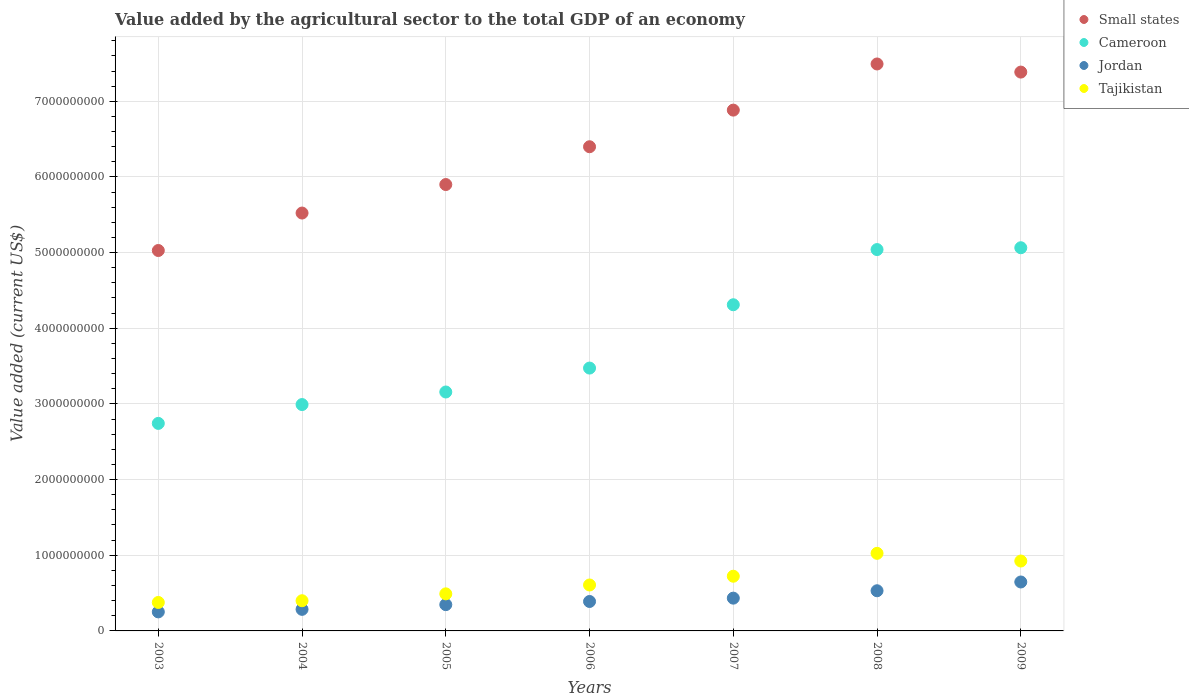Is the number of dotlines equal to the number of legend labels?
Provide a succinct answer. Yes. What is the value added by the agricultural sector to the total GDP in Small states in 2008?
Provide a short and direct response. 7.49e+09. Across all years, what is the maximum value added by the agricultural sector to the total GDP in Cameroon?
Make the answer very short. 5.06e+09. Across all years, what is the minimum value added by the agricultural sector to the total GDP in Tajikistan?
Your response must be concise. 3.76e+08. In which year was the value added by the agricultural sector to the total GDP in Jordan maximum?
Provide a short and direct response. 2009. What is the total value added by the agricultural sector to the total GDP in Jordan in the graph?
Your answer should be compact. 2.88e+09. What is the difference between the value added by the agricultural sector to the total GDP in Small states in 2007 and that in 2008?
Your answer should be compact. -6.10e+08. What is the difference between the value added by the agricultural sector to the total GDP in Tajikistan in 2003 and the value added by the agricultural sector to the total GDP in Small states in 2008?
Provide a succinct answer. -7.12e+09. What is the average value added by the agricultural sector to the total GDP in Tajikistan per year?
Offer a very short reply. 6.49e+08. In the year 2008, what is the difference between the value added by the agricultural sector to the total GDP in Jordan and value added by the agricultural sector to the total GDP in Tajikistan?
Provide a short and direct response. -4.95e+08. What is the ratio of the value added by the agricultural sector to the total GDP in Jordan in 2008 to that in 2009?
Provide a short and direct response. 0.82. What is the difference between the highest and the second highest value added by the agricultural sector to the total GDP in Tajikistan?
Your answer should be very brief. 1.02e+08. What is the difference between the highest and the lowest value added by the agricultural sector to the total GDP in Cameroon?
Give a very brief answer. 2.32e+09. In how many years, is the value added by the agricultural sector to the total GDP in Cameroon greater than the average value added by the agricultural sector to the total GDP in Cameroon taken over all years?
Ensure brevity in your answer.  3. Is the value added by the agricultural sector to the total GDP in Tajikistan strictly greater than the value added by the agricultural sector to the total GDP in Cameroon over the years?
Make the answer very short. No. Is the value added by the agricultural sector to the total GDP in Small states strictly less than the value added by the agricultural sector to the total GDP in Cameroon over the years?
Offer a very short reply. No. How many dotlines are there?
Your response must be concise. 4. What is the difference between two consecutive major ticks on the Y-axis?
Provide a short and direct response. 1.00e+09. Does the graph contain any zero values?
Provide a succinct answer. No. Where does the legend appear in the graph?
Make the answer very short. Top right. What is the title of the graph?
Make the answer very short. Value added by the agricultural sector to the total GDP of an economy. Does "Portugal" appear as one of the legend labels in the graph?
Keep it short and to the point. No. What is the label or title of the X-axis?
Your answer should be very brief. Years. What is the label or title of the Y-axis?
Offer a very short reply. Value added (current US$). What is the Value added (current US$) of Small states in 2003?
Offer a terse response. 5.03e+09. What is the Value added (current US$) in Cameroon in 2003?
Your answer should be very brief. 2.74e+09. What is the Value added (current US$) of Jordan in 2003?
Provide a succinct answer. 2.52e+08. What is the Value added (current US$) in Tajikistan in 2003?
Make the answer very short. 3.76e+08. What is the Value added (current US$) of Small states in 2004?
Ensure brevity in your answer.  5.52e+09. What is the Value added (current US$) of Cameroon in 2004?
Ensure brevity in your answer.  2.99e+09. What is the Value added (current US$) of Jordan in 2004?
Provide a succinct answer. 2.85e+08. What is the Value added (current US$) in Tajikistan in 2004?
Offer a terse response. 3.99e+08. What is the Value added (current US$) of Small states in 2005?
Provide a succinct answer. 5.90e+09. What is the Value added (current US$) of Cameroon in 2005?
Give a very brief answer. 3.16e+09. What is the Value added (current US$) in Jordan in 2005?
Offer a very short reply. 3.47e+08. What is the Value added (current US$) of Tajikistan in 2005?
Keep it short and to the point. 4.90e+08. What is the Value added (current US$) of Small states in 2006?
Your answer should be compact. 6.40e+09. What is the Value added (current US$) in Cameroon in 2006?
Your answer should be very brief. 3.47e+09. What is the Value added (current US$) in Jordan in 2006?
Offer a very short reply. 3.89e+08. What is the Value added (current US$) in Tajikistan in 2006?
Provide a succinct answer. 6.07e+08. What is the Value added (current US$) of Small states in 2007?
Your answer should be very brief. 6.88e+09. What is the Value added (current US$) in Cameroon in 2007?
Ensure brevity in your answer.  4.31e+09. What is the Value added (current US$) of Jordan in 2007?
Your answer should be compact. 4.33e+08. What is the Value added (current US$) in Tajikistan in 2007?
Offer a very short reply. 7.23e+08. What is the Value added (current US$) of Small states in 2008?
Offer a very short reply. 7.49e+09. What is the Value added (current US$) in Cameroon in 2008?
Keep it short and to the point. 5.04e+09. What is the Value added (current US$) of Jordan in 2008?
Offer a terse response. 5.31e+08. What is the Value added (current US$) of Tajikistan in 2008?
Give a very brief answer. 1.03e+09. What is the Value added (current US$) in Small states in 2009?
Provide a short and direct response. 7.39e+09. What is the Value added (current US$) of Cameroon in 2009?
Offer a terse response. 5.06e+09. What is the Value added (current US$) of Jordan in 2009?
Ensure brevity in your answer.  6.47e+08. What is the Value added (current US$) in Tajikistan in 2009?
Provide a short and direct response. 9.24e+08. Across all years, what is the maximum Value added (current US$) in Small states?
Offer a very short reply. 7.49e+09. Across all years, what is the maximum Value added (current US$) of Cameroon?
Provide a short and direct response. 5.06e+09. Across all years, what is the maximum Value added (current US$) in Jordan?
Make the answer very short. 6.47e+08. Across all years, what is the maximum Value added (current US$) in Tajikistan?
Provide a short and direct response. 1.03e+09. Across all years, what is the minimum Value added (current US$) in Small states?
Your answer should be very brief. 5.03e+09. Across all years, what is the minimum Value added (current US$) in Cameroon?
Keep it short and to the point. 2.74e+09. Across all years, what is the minimum Value added (current US$) of Jordan?
Offer a terse response. 2.52e+08. Across all years, what is the minimum Value added (current US$) of Tajikistan?
Your response must be concise. 3.76e+08. What is the total Value added (current US$) of Small states in the graph?
Offer a very short reply. 4.46e+1. What is the total Value added (current US$) in Cameroon in the graph?
Give a very brief answer. 2.68e+1. What is the total Value added (current US$) of Jordan in the graph?
Give a very brief answer. 2.88e+09. What is the total Value added (current US$) in Tajikistan in the graph?
Make the answer very short. 4.54e+09. What is the difference between the Value added (current US$) in Small states in 2003 and that in 2004?
Your answer should be very brief. -4.95e+08. What is the difference between the Value added (current US$) in Cameroon in 2003 and that in 2004?
Provide a short and direct response. -2.49e+08. What is the difference between the Value added (current US$) in Jordan in 2003 and that in 2004?
Offer a very short reply. -3.35e+07. What is the difference between the Value added (current US$) in Tajikistan in 2003 and that in 2004?
Offer a very short reply. -2.28e+07. What is the difference between the Value added (current US$) in Small states in 2003 and that in 2005?
Provide a succinct answer. -8.72e+08. What is the difference between the Value added (current US$) of Cameroon in 2003 and that in 2005?
Give a very brief answer. -4.15e+08. What is the difference between the Value added (current US$) in Jordan in 2003 and that in 2005?
Offer a terse response. -9.57e+07. What is the difference between the Value added (current US$) of Tajikistan in 2003 and that in 2005?
Your answer should be very brief. -1.14e+08. What is the difference between the Value added (current US$) in Small states in 2003 and that in 2006?
Offer a terse response. -1.37e+09. What is the difference between the Value added (current US$) in Cameroon in 2003 and that in 2006?
Give a very brief answer. -7.31e+08. What is the difference between the Value added (current US$) of Jordan in 2003 and that in 2006?
Ensure brevity in your answer.  -1.38e+08. What is the difference between the Value added (current US$) of Tajikistan in 2003 and that in 2006?
Provide a short and direct response. -2.31e+08. What is the difference between the Value added (current US$) of Small states in 2003 and that in 2007?
Ensure brevity in your answer.  -1.86e+09. What is the difference between the Value added (current US$) in Cameroon in 2003 and that in 2007?
Give a very brief answer. -1.57e+09. What is the difference between the Value added (current US$) in Jordan in 2003 and that in 2007?
Your response must be concise. -1.82e+08. What is the difference between the Value added (current US$) of Tajikistan in 2003 and that in 2007?
Offer a terse response. -3.47e+08. What is the difference between the Value added (current US$) of Small states in 2003 and that in 2008?
Your answer should be very brief. -2.47e+09. What is the difference between the Value added (current US$) in Cameroon in 2003 and that in 2008?
Your answer should be compact. -2.30e+09. What is the difference between the Value added (current US$) of Jordan in 2003 and that in 2008?
Your answer should be compact. -2.79e+08. What is the difference between the Value added (current US$) of Tajikistan in 2003 and that in 2008?
Your answer should be compact. -6.49e+08. What is the difference between the Value added (current US$) of Small states in 2003 and that in 2009?
Offer a very short reply. -2.36e+09. What is the difference between the Value added (current US$) of Cameroon in 2003 and that in 2009?
Offer a terse response. -2.32e+09. What is the difference between the Value added (current US$) in Jordan in 2003 and that in 2009?
Provide a short and direct response. -3.95e+08. What is the difference between the Value added (current US$) in Tajikistan in 2003 and that in 2009?
Provide a succinct answer. -5.48e+08. What is the difference between the Value added (current US$) of Small states in 2004 and that in 2005?
Offer a very short reply. -3.77e+08. What is the difference between the Value added (current US$) of Cameroon in 2004 and that in 2005?
Offer a very short reply. -1.66e+08. What is the difference between the Value added (current US$) in Jordan in 2004 and that in 2005?
Provide a short and direct response. -6.22e+07. What is the difference between the Value added (current US$) of Tajikistan in 2004 and that in 2005?
Your answer should be compact. -9.09e+07. What is the difference between the Value added (current US$) in Small states in 2004 and that in 2006?
Your response must be concise. -8.76e+08. What is the difference between the Value added (current US$) in Cameroon in 2004 and that in 2006?
Your answer should be compact. -4.82e+08. What is the difference between the Value added (current US$) in Jordan in 2004 and that in 2006?
Provide a short and direct response. -1.04e+08. What is the difference between the Value added (current US$) of Tajikistan in 2004 and that in 2006?
Your answer should be compact. -2.08e+08. What is the difference between the Value added (current US$) of Small states in 2004 and that in 2007?
Provide a succinct answer. -1.36e+09. What is the difference between the Value added (current US$) of Cameroon in 2004 and that in 2007?
Provide a succinct answer. -1.32e+09. What is the difference between the Value added (current US$) in Jordan in 2004 and that in 2007?
Ensure brevity in your answer.  -1.48e+08. What is the difference between the Value added (current US$) of Tajikistan in 2004 and that in 2007?
Offer a terse response. -3.24e+08. What is the difference between the Value added (current US$) in Small states in 2004 and that in 2008?
Give a very brief answer. -1.97e+09. What is the difference between the Value added (current US$) in Cameroon in 2004 and that in 2008?
Your answer should be compact. -2.05e+09. What is the difference between the Value added (current US$) of Jordan in 2004 and that in 2008?
Your answer should be very brief. -2.46e+08. What is the difference between the Value added (current US$) of Tajikistan in 2004 and that in 2008?
Provide a short and direct response. -6.26e+08. What is the difference between the Value added (current US$) in Small states in 2004 and that in 2009?
Ensure brevity in your answer.  -1.86e+09. What is the difference between the Value added (current US$) in Cameroon in 2004 and that in 2009?
Keep it short and to the point. -2.07e+09. What is the difference between the Value added (current US$) in Jordan in 2004 and that in 2009?
Give a very brief answer. -3.62e+08. What is the difference between the Value added (current US$) in Tajikistan in 2004 and that in 2009?
Your response must be concise. -5.25e+08. What is the difference between the Value added (current US$) of Small states in 2005 and that in 2006?
Offer a very short reply. -5.00e+08. What is the difference between the Value added (current US$) in Cameroon in 2005 and that in 2006?
Your answer should be very brief. -3.16e+08. What is the difference between the Value added (current US$) in Jordan in 2005 and that in 2006?
Offer a very short reply. -4.18e+07. What is the difference between the Value added (current US$) of Tajikistan in 2005 and that in 2006?
Provide a short and direct response. -1.17e+08. What is the difference between the Value added (current US$) in Small states in 2005 and that in 2007?
Make the answer very short. -9.84e+08. What is the difference between the Value added (current US$) in Cameroon in 2005 and that in 2007?
Offer a terse response. -1.15e+09. What is the difference between the Value added (current US$) in Jordan in 2005 and that in 2007?
Give a very brief answer. -8.59e+07. What is the difference between the Value added (current US$) in Tajikistan in 2005 and that in 2007?
Offer a very short reply. -2.33e+08. What is the difference between the Value added (current US$) of Small states in 2005 and that in 2008?
Offer a terse response. -1.59e+09. What is the difference between the Value added (current US$) of Cameroon in 2005 and that in 2008?
Provide a succinct answer. -1.88e+09. What is the difference between the Value added (current US$) of Jordan in 2005 and that in 2008?
Offer a very short reply. -1.84e+08. What is the difference between the Value added (current US$) in Tajikistan in 2005 and that in 2008?
Ensure brevity in your answer.  -5.35e+08. What is the difference between the Value added (current US$) in Small states in 2005 and that in 2009?
Provide a short and direct response. -1.49e+09. What is the difference between the Value added (current US$) of Cameroon in 2005 and that in 2009?
Your answer should be very brief. -1.91e+09. What is the difference between the Value added (current US$) of Jordan in 2005 and that in 2009?
Give a very brief answer. -2.99e+08. What is the difference between the Value added (current US$) in Tajikistan in 2005 and that in 2009?
Your answer should be very brief. -4.34e+08. What is the difference between the Value added (current US$) of Small states in 2006 and that in 2007?
Ensure brevity in your answer.  -4.84e+08. What is the difference between the Value added (current US$) in Cameroon in 2006 and that in 2007?
Offer a very short reply. -8.37e+08. What is the difference between the Value added (current US$) in Jordan in 2006 and that in 2007?
Ensure brevity in your answer.  -4.41e+07. What is the difference between the Value added (current US$) of Tajikistan in 2006 and that in 2007?
Ensure brevity in your answer.  -1.16e+08. What is the difference between the Value added (current US$) in Small states in 2006 and that in 2008?
Provide a short and direct response. -1.09e+09. What is the difference between the Value added (current US$) of Cameroon in 2006 and that in 2008?
Ensure brevity in your answer.  -1.57e+09. What is the difference between the Value added (current US$) of Jordan in 2006 and that in 2008?
Make the answer very short. -1.42e+08. What is the difference between the Value added (current US$) in Tajikistan in 2006 and that in 2008?
Ensure brevity in your answer.  -4.18e+08. What is the difference between the Value added (current US$) of Small states in 2006 and that in 2009?
Provide a short and direct response. -9.87e+08. What is the difference between the Value added (current US$) of Cameroon in 2006 and that in 2009?
Provide a short and direct response. -1.59e+09. What is the difference between the Value added (current US$) of Jordan in 2006 and that in 2009?
Provide a short and direct response. -2.58e+08. What is the difference between the Value added (current US$) in Tajikistan in 2006 and that in 2009?
Make the answer very short. -3.17e+08. What is the difference between the Value added (current US$) in Small states in 2007 and that in 2008?
Your answer should be compact. -6.10e+08. What is the difference between the Value added (current US$) of Cameroon in 2007 and that in 2008?
Offer a terse response. -7.29e+08. What is the difference between the Value added (current US$) of Jordan in 2007 and that in 2008?
Your answer should be very brief. -9.77e+07. What is the difference between the Value added (current US$) of Tajikistan in 2007 and that in 2008?
Provide a short and direct response. -3.03e+08. What is the difference between the Value added (current US$) of Small states in 2007 and that in 2009?
Offer a very short reply. -5.03e+08. What is the difference between the Value added (current US$) of Cameroon in 2007 and that in 2009?
Give a very brief answer. -7.53e+08. What is the difference between the Value added (current US$) in Jordan in 2007 and that in 2009?
Ensure brevity in your answer.  -2.14e+08. What is the difference between the Value added (current US$) of Tajikistan in 2007 and that in 2009?
Keep it short and to the point. -2.01e+08. What is the difference between the Value added (current US$) of Small states in 2008 and that in 2009?
Ensure brevity in your answer.  1.07e+08. What is the difference between the Value added (current US$) in Cameroon in 2008 and that in 2009?
Your response must be concise. -2.41e+07. What is the difference between the Value added (current US$) of Jordan in 2008 and that in 2009?
Your response must be concise. -1.16e+08. What is the difference between the Value added (current US$) in Tajikistan in 2008 and that in 2009?
Provide a succinct answer. 1.02e+08. What is the difference between the Value added (current US$) of Small states in 2003 and the Value added (current US$) of Cameroon in 2004?
Make the answer very short. 2.04e+09. What is the difference between the Value added (current US$) in Small states in 2003 and the Value added (current US$) in Jordan in 2004?
Offer a terse response. 4.74e+09. What is the difference between the Value added (current US$) of Small states in 2003 and the Value added (current US$) of Tajikistan in 2004?
Offer a very short reply. 4.63e+09. What is the difference between the Value added (current US$) of Cameroon in 2003 and the Value added (current US$) of Jordan in 2004?
Provide a short and direct response. 2.46e+09. What is the difference between the Value added (current US$) of Cameroon in 2003 and the Value added (current US$) of Tajikistan in 2004?
Your answer should be very brief. 2.34e+09. What is the difference between the Value added (current US$) of Jordan in 2003 and the Value added (current US$) of Tajikistan in 2004?
Offer a terse response. -1.48e+08. What is the difference between the Value added (current US$) of Small states in 2003 and the Value added (current US$) of Cameroon in 2005?
Provide a succinct answer. 1.87e+09. What is the difference between the Value added (current US$) in Small states in 2003 and the Value added (current US$) in Jordan in 2005?
Your answer should be compact. 4.68e+09. What is the difference between the Value added (current US$) in Small states in 2003 and the Value added (current US$) in Tajikistan in 2005?
Provide a succinct answer. 4.54e+09. What is the difference between the Value added (current US$) in Cameroon in 2003 and the Value added (current US$) in Jordan in 2005?
Ensure brevity in your answer.  2.40e+09. What is the difference between the Value added (current US$) of Cameroon in 2003 and the Value added (current US$) of Tajikistan in 2005?
Provide a succinct answer. 2.25e+09. What is the difference between the Value added (current US$) of Jordan in 2003 and the Value added (current US$) of Tajikistan in 2005?
Give a very brief answer. -2.39e+08. What is the difference between the Value added (current US$) of Small states in 2003 and the Value added (current US$) of Cameroon in 2006?
Your answer should be compact. 1.55e+09. What is the difference between the Value added (current US$) in Small states in 2003 and the Value added (current US$) in Jordan in 2006?
Make the answer very short. 4.64e+09. What is the difference between the Value added (current US$) in Small states in 2003 and the Value added (current US$) in Tajikistan in 2006?
Keep it short and to the point. 4.42e+09. What is the difference between the Value added (current US$) of Cameroon in 2003 and the Value added (current US$) of Jordan in 2006?
Your answer should be compact. 2.35e+09. What is the difference between the Value added (current US$) of Cameroon in 2003 and the Value added (current US$) of Tajikistan in 2006?
Keep it short and to the point. 2.14e+09. What is the difference between the Value added (current US$) of Jordan in 2003 and the Value added (current US$) of Tajikistan in 2006?
Give a very brief answer. -3.56e+08. What is the difference between the Value added (current US$) of Small states in 2003 and the Value added (current US$) of Cameroon in 2007?
Your answer should be very brief. 7.17e+08. What is the difference between the Value added (current US$) in Small states in 2003 and the Value added (current US$) in Jordan in 2007?
Offer a very short reply. 4.59e+09. What is the difference between the Value added (current US$) in Small states in 2003 and the Value added (current US$) in Tajikistan in 2007?
Make the answer very short. 4.30e+09. What is the difference between the Value added (current US$) of Cameroon in 2003 and the Value added (current US$) of Jordan in 2007?
Offer a very short reply. 2.31e+09. What is the difference between the Value added (current US$) of Cameroon in 2003 and the Value added (current US$) of Tajikistan in 2007?
Make the answer very short. 2.02e+09. What is the difference between the Value added (current US$) of Jordan in 2003 and the Value added (current US$) of Tajikistan in 2007?
Your response must be concise. -4.71e+08. What is the difference between the Value added (current US$) in Small states in 2003 and the Value added (current US$) in Cameroon in 2008?
Provide a short and direct response. -1.24e+07. What is the difference between the Value added (current US$) of Small states in 2003 and the Value added (current US$) of Jordan in 2008?
Ensure brevity in your answer.  4.50e+09. What is the difference between the Value added (current US$) in Small states in 2003 and the Value added (current US$) in Tajikistan in 2008?
Ensure brevity in your answer.  4.00e+09. What is the difference between the Value added (current US$) in Cameroon in 2003 and the Value added (current US$) in Jordan in 2008?
Make the answer very short. 2.21e+09. What is the difference between the Value added (current US$) in Cameroon in 2003 and the Value added (current US$) in Tajikistan in 2008?
Make the answer very short. 1.72e+09. What is the difference between the Value added (current US$) of Jordan in 2003 and the Value added (current US$) of Tajikistan in 2008?
Ensure brevity in your answer.  -7.74e+08. What is the difference between the Value added (current US$) in Small states in 2003 and the Value added (current US$) in Cameroon in 2009?
Give a very brief answer. -3.65e+07. What is the difference between the Value added (current US$) in Small states in 2003 and the Value added (current US$) in Jordan in 2009?
Provide a succinct answer. 4.38e+09. What is the difference between the Value added (current US$) of Small states in 2003 and the Value added (current US$) of Tajikistan in 2009?
Provide a short and direct response. 4.10e+09. What is the difference between the Value added (current US$) in Cameroon in 2003 and the Value added (current US$) in Jordan in 2009?
Provide a succinct answer. 2.10e+09. What is the difference between the Value added (current US$) of Cameroon in 2003 and the Value added (current US$) of Tajikistan in 2009?
Give a very brief answer. 1.82e+09. What is the difference between the Value added (current US$) in Jordan in 2003 and the Value added (current US$) in Tajikistan in 2009?
Provide a succinct answer. -6.72e+08. What is the difference between the Value added (current US$) of Small states in 2004 and the Value added (current US$) of Cameroon in 2005?
Keep it short and to the point. 2.37e+09. What is the difference between the Value added (current US$) of Small states in 2004 and the Value added (current US$) of Jordan in 2005?
Your answer should be compact. 5.18e+09. What is the difference between the Value added (current US$) of Small states in 2004 and the Value added (current US$) of Tajikistan in 2005?
Give a very brief answer. 5.03e+09. What is the difference between the Value added (current US$) in Cameroon in 2004 and the Value added (current US$) in Jordan in 2005?
Your answer should be compact. 2.64e+09. What is the difference between the Value added (current US$) in Cameroon in 2004 and the Value added (current US$) in Tajikistan in 2005?
Provide a succinct answer. 2.50e+09. What is the difference between the Value added (current US$) of Jordan in 2004 and the Value added (current US$) of Tajikistan in 2005?
Provide a succinct answer. -2.05e+08. What is the difference between the Value added (current US$) of Small states in 2004 and the Value added (current US$) of Cameroon in 2006?
Make the answer very short. 2.05e+09. What is the difference between the Value added (current US$) in Small states in 2004 and the Value added (current US$) in Jordan in 2006?
Ensure brevity in your answer.  5.13e+09. What is the difference between the Value added (current US$) in Small states in 2004 and the Value added (current US$) in Tajikistan in 2006?
Your answer should be compact. 4.92e+09. What is the difference between the Value added (current US$) of Cameroon in 2004 and the Value added (current US$) of Jordan in 2006?
Your response must be concise. 2.60e+09. What is the difference between the Value added (current US$) of Cameroon in 2004 and the Value added (current US$) of Tajikistan in 2006?
Ensure brevity in your answer.  2.38e+09. What is the difference between the Value added (current US$) in Jordan in 2004 and the Value added (current US$) in Tajikistan in 2006?
Your response must be concise. -3.22e+08. What is the difference between the Value added (current US$) of Small states in 2004 and the Value added (current US$) of Cameroon in 2007?
Your answer should be very brief. 1.21e+09. What is the difference between the Value added (current US$) in Small states in 2004 and the Value added (current US$) in Jordan in 2007?
Keep it short and to the point. 5.09e+09. What is the difference between the Value added (current US$) in Small states in 2004 and the Value added (current US$) in Tajikistan in 2007?
Keep it short and to the point. 4.80e+09. What is the difference between the Value added (current US$) of Cameroon in 2004 and the Value added (current US$) of Jordan in 2007?
Your answer should be compact. 2.56e+09. What is the difference between the Value added (current US$) of Cameroon in 2004 and the Value added (current US$) of Tajikistan in 2007?
Ensure brevity in your answer.  2.27e+09. What is the difference between the Value added (current US$) of Jordan in 2004 and the Value added (current US$) of Tajikistan in 2007?
Keep it short and to the point. -4.38e+08. What is the difference between the Value added (current US$) in Small states in 2004 and the Value added (current US$) in Cameroon in 2008?
Give a very brief answer. 4.83e+08. What is the difference between the Value added (current US$) in Small states in 2004 and the Value added (current US$) in Jordan in 2008?
Your answer should be very brief. 4.99e+09. What is the difference between the Value added (current US$) in Small states in 2004 and the Value added (current US$) in Tajikistan in 2008?
Make the answer very short. 4.50e+09. What is the difference between the Value added (current US$) in Cameroon in 2004 and the Value added (current US$) in Jordan in 2008?
Offer a very short reply. 2.46e+09. What is the difference between the Value added (current US$) of Cameroon in 2004 and the Value added (current US$) of Tajikistan in 2008?
Offer a very short reply. 1.97e+09. What is the difference between the Value added (current US$) in Jordan in 2004 and the Value added (current US$) in Tajikistan in 2008?
Your answer should be very brief. -7.40e+08. What is the difference between the Value added (current US$) of Small states in 2004 and the Value added (current US$) of Cameroon in 2009?
Provide a short and direct response. 4.59e+08. What is the difference between the Value added (current US$) of Small states in 2004 and the Value added (current US$) of Jordan in 2009?
Your answer should be compact. 4.88e+09. What is the difference between the Value added (current US$) in Small states in 2004 and the Value added (current US$) in Tajikistan in 2009?
Your answer should be very brief. 4.60e+09. What is the difference between the Value added (current US$) in Cameroon in 2004 and the Value added (current US$) in Jordan in 2009?
Give a very brief answer. 2.34e+09. What is the difference between the Value added (current US$) in Cameroon in 2004 and the Value added (current US$) in Tajikistan in 2009?
Make the answer very short. 2.07e+09. What is the difference between the Value added (current US$) of Jordan in 2004 and the Value added (current US$) of Tajikistan in 2009?
Your response must be concise. -6.39e+08. What is the difference between the Value added (current US$) in Small states in 2005 and the Value added (current US$) in Cameroon in 2006?
Provide a short and direct response. 2.43e+09. What is the difference between the Value added (current US$) of Small states in 2005 and the Value added (current US$) of Jordan in 2006?
Your answer should be compact. 5.51e+09. What is the difference between the Value added (current US$) in Small states in 2005 and the Value added (current US$) in Tajikistan in 2006?
Provide a short and direct response. 5.29e+09. What is the difference between the Value added (current US$) of Cameroon in 2005 and the Value added (current US$) of Jordan in 2006?
Provide a succinct answer. 2.77e+09. What is the difference between the Value added (current US$) in Cameroon in 2005 and the Value added (current US$) in Tajikistan in 2006?
Your response must be concise. 2.55e+09. What is the difference between the Value added (current US$) in Jordan in 2005 and the Value added (current US$) in Tajikistan in 2006?
Ensure brevity in your answer.  -2.60e+08. What is the difference between the Value added (current US$) in Small states in 2005 and the Value added (current US$) in Cameroon in 2007?
Ensure brevity in your answer.  1.59e+09. What is the difference between the Value added (current US$) in Small states in 2005 and the Value added (current US$) in Jordan in 2007?
Ensure brevity in your answer.  5.47e+09. What is the difference between the Value added (current US$) of Small states in 2005 and the Value added (current US$) of Tajikistan in 2007?
Offer a very short reply. 5.18e+09. What is the difference between the Value added (current US$) of Cameroon in 2005 and the Value added (current US$) of Jordan in 2007?
Make the answer very short. 2.72e+09. What is the difference between the Value added (current US$) of Cameroon in 2005 and the Value added (current US$) of Tajikistan in 2007?
Give a very brief answer. 2.43e+09. What is the difference between the Value added (current US$) of Jordan in 2005 and the Value added (current US$) of Tajikistan in 2007?
Offer a terse response. -3.76e+08. What is the difference between the Value added (current US$) of Small states in 2005 and the Value added (current US$) of Cameroon in 2008?
Ensure brevity in your answer.  8.59e+08. What is the difference between the Value added (current US$) of Small states in 2005 and the Value added (current US$) of Jordan in 2008?
Make the answer very short. 5.37e+09. What is the difference between the Value added (current US$) in Small states in 2005 and the Value added (current US$) in Tajikistan in 2008?
Provide a succinct answer. 4.87e+09. What is the difference between the Value added (current US$) in Cameroon in 2005 and the Value added (current US$) in Jordan in 2008?
Make the answer very short. 2.63e+09. What is the difference between the Value added (current US$) of Cameroon in 2005 and the Value added (current US$) of Tajikistan in 2008?
Provide a short and direct response. 2.13e+09. What is the difference between the Value added (current US$) in Jordan in 2005 and the Value added (current US$) in Tajikistan in 2008?
Your answer should be compact. -6.78e+08. What is the difference between the Value added (current US$) in Small states in 2005 and the Value added (current US$) in Cameroon in 2009?
Keep it short and to the point. 8.35e+08. What is the difference between the Value added (current US$) in Small states in 2005 and the Value added (current US$) in Jordan in 2009?
Your answer should be very brief. 5.25e+09. What is the difference between the Value added (current US$) of Small states in 2005 and the Value added (current US$) of Tajikistan in 2009?
Provide a succinct answer. 4.98e+09. What is the difference between the Value added (current US$) in Cameroon in 2005 and the Value added (current US$) in Jordan in 2009?
Your answer should be compact. 2.51e+09. What is the difference between the Value added (current US$) in Cameroon in 2005 and the Value added (current US$) in Tajikistan in 2009?
Offer a terse response. 2.23e+09. What is the difference between the Value added (current US$) in Jordan in 2005 and the Value added (current US$) in Tajikistan in 2009?
Your answer should be very brief. -5.77e+08. What is the difference between the Value added (current US$) in Small states in 2006 and the Value added (current US$) in Cameroon in 2007?
Ensure brevity in your answer.  2.09e+09. What is the difference between the Value added (current US$) of Small states in 2006 and the Value added (current US$) of Jordan in 2007?
Provide a short and direct response. 5.97e+09. What is the difference between the Value added (current US$) in Small states in 2006 and the Value added (current US$) in Tajikistan in 2007?
Provide a succinct answer. 5.68e+09. What is the difference between the Value added (current US$) in Cameroon in 2006 and the Value added (current US$) in Jordan in 2007?
Provide a short and direct response. 3.04e+09. What is the difference between the Value added (current US$) in Cameroon in 2006 and the Value added (current US$) in Tajikistan in 2007?
Make the answer very short. 2.75e+09. What is the difference between the Value added (current US$) in Jordan in 2006 and the Value added (current US$) in Tajikistan in 2007?
Ensure brevity in your answer.  -3.34e+08. What is the difference between the Value added (current US$) in Small states in 2006 and the Value added (current US$) in Cameroon in 2008?
Keep it short and to the point. 1.36e+09. What is the difference between the Value added (current US$) of Small states in 2006 and the Value added (current US$) of Jordan in 2008?
Ensure brevity in your answer.  5.87e+09. What is the difference between the Value added (current US$) of Small states in 2006 and the Value added (current US$) of Tajikistan in 2008?
Provide a succinct answer. 5.37e+09. What is the difference between the Value added (current US$) of Cameroon in 2006 and the Value added (current US$) of Jordan in 2008?
Offer a very short reply. 2.94e+09. What is the difference between the Value added (current US$) in Cameroon in 2006 and the Value added (current US$) in Tajikistan in 2008?
Your response must be concise. 2.45e+09. What is the difference between the Value added (current US$) in Jordan in 2006 and the Value added (current US$) in Tajikistan in 2008?
Ensure brevity in your answer.  -6.36e+08. What is the difference between the Value added (current US$) of Small states in 2006 and the Value added (current US$) of Cameroon in 2009?
Your answer should be very brief. 1.33e+09. What is the difference between the Value added (current US$) in Small states in 2006 and the Value added (current US$) in Jordan in 2009?
Make the answer very short. 5.75e+09. What is the difference between the Value added (current US$) of Small states in 2006 and the Value added (current US$) of Tajikistan in 2009?
Your answer should be very brief. 5.48e+09. What is the difference between the Value added (current US$) in Cameroon in 2006 and the Value added (current US$) in Jordan in 2009?
Offer a terse response. 2.83e+09. What is the difference between the Value added (current US$) in Cameroon in 2006 and the Value added (current US$) in Tajikistan in 2009?
Your answer should be compact. 2.55e+09. What is the difference between the Value added (current US$) of Jordan in 2006 and the Value added (current US$) of Tajikistan in 2009?
Provide a succinct answer. -5.35e+08. What is the difference between the Value added (current US$) of Small states in 2007 and the Value added (current US$) of Cameroon in 2008?
Ensure brevity in your answer.  1.84e+09. What is the difference between the Value added (current US$) in Small states in 2007 and the Value added (current US$) in Jordan in 2008?
Offer a very short reply. 6.35e+09. What is the difference between the Value added (current US$) in Small states in 2007 and the Value added (current US$) in Tajikistan in 2008?
Offer a terse response. 5.86e+09. What is the difference between the Value added (current US$) of Cameroon in 2007 and the Value added (current US$) of Jordan in 2008?
Offer a very short reply. 3.78e+09. What is the difference between the Value added (current US$) of Cameroon in 2007 and the Value added (current US$) of Tajikistan in 2008?
Keep it short and to the point. 3.29e+09. What is the difference between the Value added (current US$) in Jordan in 2007 and the Value added (current US$) in Tajikistan in 2008?
Your answer should be compact. -5.92e+08. What is the difference between the Value added (current US$) of Small states in 2007 and the Value added (current US$) of Cameroon in 2009?
Your response must be concise. 1.82e+09. What is the difference between the Value added (current US$) in Small states in 2007 and the Value added (current US$) in Jordan in 2009?
Ensure brevity in your answer.  6.24e+09. What is the difference between the Value added (current US$) in Small states in 2007 and the Value added (current US$) in Tajikistan in 2009?
Offer a terse response. 5.96e+09. What is the difference between the Value added (current US$) in Cameroon in 2007 and the Value added (current US$) in Jordan in 2009?
Your answer should be very brief. 3.66e+09. What is the difference between the Value added (current US$) in Cameroon in 2007 and the Value added (current US$) in Tajikistan in 2009?
Make the answer very short. 3.39e+09. What is the difference between the Value added (current US$) of Jordan in 2007 and the Value added (current US$) of Tajikistan in 2009?
Offer a terse response. -4.91e+08. What is the difference between the Value added (current US$) of Small states in 2008 and the Value added (current US$) of Cameroon in 2009?
Keep it short and to the point. 2.43e+09. What is the difference between the Value added (current US$) in Small states in 2008 and the Value added (current US$) in Jordan in 2009?
Your answer should be very brief. 6.85e+09. What is the difference between the Value added (current US$) in Small states in 2008 and the Value added (current US$) in Tajikistan in 2009?
Ensure brevity in your answer.  6.57e+09. What is the difference between the Value added (current US$) in Cameroon in 2008 and the Value added (current US$) in Jordan in 2009?
Your answer should be very brief. 4.39e+09. What is the difference between the Value added (current US$) of Cameroon in 2008 and the Value added (current US$) of Tajikistan in 2009?
Make the answer very short. 4.12e+09. What is the difference between the Value added (current US$) of Jordan in 2008 and the Value added (current US$) of Tajikistan in 2009?
Your answer should be compact. -3.93e+08. What is the average Value added (current US$) of Small states per year?
Keep it short and to the point. 6.37e+09. What is the average Value added (current US$) of Cameroon per year?
Make the answer very short. 3.83e+09. What is the average Value added (current US$) of Jordan per year?
Your answer should be very brief. 4.12e+08. What is the average Value added (current US$) of Tajikistan per year?
Offer a very short reply. 6.49e+08. In the year 2003, what is the difference between the Value added (current US$) in Small states and Value added (current US$) in Cameroon?
Offer a terse response. 2.28e+09. In the year 2003, what is the difference between the Value added (current US$) in Small states and Value added (current US$) in Jordan?
Offer a very short reply. 4.78e+09. In the year 2003, what is the difference between the Value added (current US$) of Small states and Value added (current US$) of Tajikistan?
Provide a short and direct response. 4.65e+09. In the year 2003, what is the difference between the Value added (current US$) of Cameroon and Value added (current US$) of Jordan?
Your response must be concise. 2.49e+09. In the year 2003, what is the difference between the Value added (current US$) in Cameroon and Value added (current US$) in Tajikistan?
Offer a terse response. 2.37e+09. In the year 2003, what is the difference between the Value added (current US$) of Jordan and Value added (current US$) of Tajikistan?
Provide a short and direct response. -1.25e+08. In the year 2004, what is the difference between the Value added (current US$) of Small states and Value added (current US$) of Cameroon?
Offer a terse response. 2.53e+09. In the year 2004, what is the difference between the Value added (current US$) in Small states and Value added (current US$) in Jordan?
Give a very brief answer. 5.24e+09. In the year 2004, what is the difference between the Value added (current US$) of Small states and Value added (current US$) of Tajikistan?
Provide a short and direct response. 5.12e+09. In the year 2004, what is the difference between the Value added (current US$) of Cameroon and Value added (current US$) of Jordan?
Provide a succinct answer. 2.71e+09. In the year 2004, what is the difference between the Value added (current US$) of Cameroon and Value added (current US$) of Tajikistan?
Offer a terse response. 2.59e+09. In the year 2004, what is the difference between the Value added (current US$) of Jordan and Value added (current US$) of Tajikistan?
Your response must be concise. -1.14e+08. In the year 2005, what is the difference between the Value added (current US$) of Small states and Value added (current US$) of Cameroon?
Offer a very short reply. 2.74e+09. In the year 2005, what is the difference between the Value added (current US$) in Small states and Value added (current US$) in Jordan?
Provide a short and direct response. 5.55e+09. In the year 2005, what is the difference between the Value added (current US$) of Small states and Value added (current US$) of Tajikistan?
Give a very brief answer. 5.41e+09. In the year 2005, what is the difference between the Value added (current US$) in Cameroon and Value added (current US$) in Jordan?
Your answer should be compact. 2.81e+09. In the year 2005, what is the difference between the Value added (current US$) of Cameroon and Value added (current US$) of Tajikistan?
Your response must be concise. 2.67e+09. In the year 2005, what is the difference between the Value added (current US$) in Jordan and Value added (current US$) in Tajikistan?
Make the answer very short. -1.43e+08. In the year 2006, what is the difference between the Value added (current US$) of Small states and Value added (current US$) of Cameroon?
Ensure brevity in your answer.  2.93e+09. In the year 2006, what is the difference between the Value added (current US$) in Small states and Value added (current US$) in Jordan?
Ensure brevity in your answer.  6.01e+09. In the year 2006, what is the difference between the Value added (current US$) in Small states and Value added (current US$) in Tajikistan?
Your answer should be very brief. 5.79e+09. In the year 2006, what is the difference between the Value added (current US$) of Cameroon and Value added (current US$) of Jordan?
Offer a terse response. 3.08e+09. In the year 2006, what is the difference between the Value added (current US$) of Cameroon and Value added (current US$) of Tajikistan?
Keep it short and to the point. 2.87e+09. In the year 2006, what is the difference between the Value added (current US$) of Jordan and Value added (current US$) of Tajikistan?
Give a very brief answer. -2.18e+08. In the year 2007, what is the difference between the Value added (current US$) in Small states and Value added (current US$) in Cameroon?
Give a very brief answer. 2.57e+09. In the year 2007, what is the difference between the Value added (current US$) in Small states and Value added (current US$) in Jordan?
Offer a very short reply. 6.45e+09. In the year 2007, what is the difference between the Value added (current US$) of Small states and Value added (current US$) of Tajikistan?
Provide a short and direct response. 6.16e+09. In the year 2007, what is the difference between the Value added (current US$) in Cameroon and Value added (current US$) in Jordan?
Offer a very short reply. 3.88e+09. In the year 2007, what is the difference between the Value added (current US$) in Cameroon and Value added (current US$) in Tajikistan?
Keep it short and to the point. 3.59e+09. In the year 2007, what is the difference between the Value added (current US$) in Jordan and Value added (current US$) in Tajikistan?
Ensure brevity in your answer.  -2.90e+08. In the year 2008, what is the difference between the Value added (current US$) of Small states and Value added (current US$) of Cameroon?
Your answer should be very brief. 2.45e+09. In the year 2008, what is the difference between the Value added (current US$) of Small states and Value added (current US$) of Jordan?
Your response must be concise. 6.96e+09. In the year 2008, what is the difference between the Value added (current US$) in Small states and Value added (current US$) in Tajikistan?
Provide a succinct answer. 6.47e+09. In the year 2008, what is the difference between the Value added (current US$) in Cameroon and Value added (current US$) in Jordan?
Make the answer very short. 4.51e+09. In the year 2008, what is the difference between the Value added (current US$) of Cameroon and Value added (current US$) of Tajikistan?
Keep it short and to the point. 4.01e+09. In the year 2008, what is the difference between the Value added (current US$) of Jordan and Value added (current US$) of Tajikistan?
Give a very brief answer. -4.95e+08. In the year 2009, what is the difference between the Value added (current US$) of Small states and Value added (current US$) of Cameroon?
Your response must be concise. 2.32e+09. In the year 2009, what is the difference between the Value added (current US$) of Small states and Value added (current US$) of Jordan?
Offer a very short reply. 6.74e+09. In the year 2009, what is the difference between the Value added (current US$) of Small states and Value added (current US$) of Tajikistan?
Offer a very short reply. 6.46e+09. In the year 2009, what is the difference between the Value added (current US$) of Cameroon and Value added (current US$) of Jordan?
Give a very brief answer. 4.42e+09. In the year 2009, what is the difference between the Value added (current US$) of Cameroon and Value added (current US$) of Tajikistan?
Your response must be concise. 4.14e+09. In the year 2009, what is the difference between the Value added (current US$) of Jordan and Value added (current US$) of Tajikistan?
Provide a succinct answer. -2.77e+08. What is the ratio of the Value added (current US$) in Small states in 2003 to that in 2004?
Offer a very short reply. 0.91. What is the ratio of the Value added (current US$) of Cameroon in 2003 to that in 2004?
Your answer should be compact. 0.92. What is the ratio of the Value added (current US$) in Jordan in 2003 to that in 2004?
Your answer should be very brief. 0.88. What is the ratio of the Value added (current US$) of Tajikistan in 2003 to that in 2004?
Provide a succinct answer. 0.94. What is the ratio of the Value added (current US$) of Small states in 2003 to that in 2005?
Ensure brevity in your answer.  0.85. What is the ratio of the Value added (current US$) of Cameroon in 2003 to that in 2005?
Offer a very short reply. 0.87. What is the ratio of the Value added (current US$) in Jordan in 2003 to that in 2005?
Make the answer very short. 0.72. What is the ratio of the Value added (current US$) in Tajikistan in 2003 to that in 2005?
Your answer should be compact. 0.77. What is the ratio of the Value added (current US$) in Small states in 2003 to that in 2006?
Keep it short and to the point. 0.79. What is the ratio of the Value added (current US$) of Cameroon in 2003 to that in 2006?
Your answer should be compact. 0.79. What is the ratio of the Value added (current US$) of Jordan in 2003 to that in 2006?
Your answer should be very brief. 0.65. What is the ratio of the Value added (current US$) in Tajikistan in 2003 to that in 2006?
Keep it short and to the point. 0.62. What is the ratio of the Value added (current US$) of Small states in 2003 to that in 2007?
Offer a very short reply. 0.73. What is the ratio of the Value added (current US$) of Cameroon in 2003 to that in 2007?
Keep it short and to the point. 0.64. What is the ratio of the Value added (current US$) of Jordan in 2003 to that in 2007?
Provide a succinct answer. 0.58. What is the ratio of the Value added (current US$) of Tajikistan in 2003 to that in 2007?
Provide a short and direct response. 0.52. What is the ratio of the Value added (current US$) in Small states in 2003 to that in 2008?
Your answer should be very brief. 0.67. What is the ratio of the Value added (current US$) in Cameroon in 2003 to that in 2008?
Offer a very short reply. 0.54. What is the ratio of the Value added (current US$) in Jordan in 2003 to that in 2008?
Keep it short and to the point. 0.47. What is the ratio of the Value added (current US$) of Tajikistan in 2003 to that in 2008?
Your answer should be very brief. 0.37. What is the ratio of the Value added (current US$) of Small states in 2003 to that in 2009?
Make the answer very short. 0.68. What is the ratio of the Value added (current US$) of Cameroon in 2003 to that in 2009?
Give a very brief answer. 0.54. What is the ratio of the Value added (current US$) of Jordan in 2003 to that in 2009?
Provide a succinct answer. 0.39. What is the ratio of the Value added (current US$) of Tajikistan in 2003 to that in 2009?
Provide a short and direct response. 0.41. What is the ratio of the Value added (current US$) in Small states in 2004 to that in 2005?
Offer a terse response. 0.94. What is the ratio of the Value added (current US$) in Jordan in 2004 to that in 2005?
Your answer should be compact. 0.82. What is the ratio of the Value added (current US$) in Tajikistan in 2004 to that in 2005?
Keep it short and to the point. 0.81. What is the ratio of the Value added (current US$) of Small states in 2004 to that in 2006?
Provide a succinct answer. 0.86. What is the ratio of the Value added (current US$) in Cameroon in 2004 to that in 2006?
Your answer should be very brief. 0.86. What is the ratio of the Value added (current US$) in Jordan in 2004 to that in 2006?
Give a very brief answer. 0.73. What is the ratio of the Value added (current US$) in Tajikistan in 2004 to that in 2006?
Ensure brevity in your answer.  0.66. What is the ratio of the Value added (current US$) of Small states in 2004 to that in 2007?
Keep it short and to the point. 0.8. What is the ratio of the Value added (current US$) in Cameroon in 2004 to that in 2007?
Your response must be concise. 0.69. What is the ratio of the Value added (current US$) in Jordan in 2004 to that in 2007?
Your answer should be compact. 0.66. What is the ratio of the Value added (current US$) of Tajikistan in 2004 to that in 2007?
Make the answer very short. 0.55. What is the ratio of the Value added (current US$) of Small states in 2004 to that in 2008?
Give a very brief answer. 0.74. What is the ratio of the Value added (current US$) in Cameroon in 2004 to that in 2008?
Your response must be concise. 0.59. What is the ratio of the Value added (current US$) of Jordan in 2004 to that in 2008?
Your answer should be compact. 0.54. What is the ratio of the Value added (current US$) in Tajikistan in 2004 to that in 2008?
Offer a terse response. 0.39. What is the ratio of the Value added (current US$) in Small states in 2004 to that in 2009?
Your answer should be compact. 0.75. What is the ratio of the Value added (current US$) in Cameroon in 2004 to that in 2009?
Your answer should be very brief. 0.59. What is the ratio of the Value added (current US$) in Jordan in 2004 to that in 2009?
Provide a short and direct response. 0.44. What is the ratio of the Value added (current US$) in Tajikistan in 2004 to that in 2009?
Your response must be concise. 0.43. What is the ratio of the Value added (current US$) in Small states in 2005 to that in 2006?
Provide a short and direct response. 0.92. What is the ratio of the Value added (current US$) in Cameroon in 2005 to that in 2006?
Keep it short and to the point. 0.91. What is the ratio of the Value added (current US$) of Jordan in 2005 to that in 2006?
Ensure brevity in your answer.  0.89. What is the ratio of the Value added (current US$) in Tajikistan in 2005 to that in 2006?
Your answer should be very brief. 0.81. What is the ratio of the Value added (current US$) of Cameroon in 2005 to that in 2007?
Keep it short and to the point. 0.73. What is the ratio of the Value added (current US$) in Jordan in 2005 to that in 2007?
Keep it short and to the point. 0.8. What is the ratio of the Value added (current US$) in Tajikistan in 2005 to that in 2007?
Provide a short and direct response. 0.68. What is the ratio of the Value added (current US$) of Small states in 2005 to that in 2008?
Make the answer very short. 0.79. What is the ratio of the Value added (current US$) in Cameroon in 2005 to that in 2008?
Provide a succinct answer. 0.63. What is the ratio of the Value added (current US$) of Jordan in 2005 to that in 2008?
Provide a succinct answer. 0.65. What is the ratio of the Value added (current US$) in Tajikistan in 2005 to that in 2008?
Give a very brief answer. 0.48. What is the ratio of the Value added (current US$) of Small states in 2005 to that in 2009?
Offer a very short reply. 0.8. What is the ratio of the Value added (current US$) in Cameroon in 2005 to that in 2009?
Keep it short and to the point. 0.62. What is the ratio of the Value added (current US$) in Jordan in 2005 to that in 2009?
Keep it short and to the point. 0.54. What is the ratio of the Value added (current US$) in Tajikistan in 2005 to that in 2009?
Keep it short and to the point. 0.53. What is the ratio of the Value added (current US$) of Small states in 2006 to that in 2007?
Your answer should be very brief. 0.93. What is the ratio of the Value added (current US$) in Cameroon in 2006 to that in 2007?
Provide a short and direct response. 0.81. What is the ratio of the Value added (current US$) of Jordan in 2006 to that in 2007?
Your response must be concise. 0.9. What is the ratio of the Value added (current US$) of Tajikistan in 2006 to that in 2007?
Provide a short and direct response. 0.84. What is the ratio of the Value added (current US$) in Small states in 2006 to that in 2008?
Your answer should be compact. 0.85. What is the ratio of the Value added (current US$) in Cameroon in 2006 to that in 2008?
Ensure brevity in your answer.  0.69. What is the ratio of the Value added (current US$) of Jordan in 2006 to that in 2008?
Keep it short and to the point. 0.73. What is the ratio of the Value added (current US$) in Tajikistan in 2006 to that in 2008?
Provide a succinct answer. 0.59. What is the ratio of the Value added (current US$) of Small states in 2006 to that in 2009?
Ensure brevity in your answer.  0.87. What is the ratio of the Value added (current US$) of Cameroon in 2006 to that in 2009?
Your answer should be compact. 0.69. What is the ratio of the Value added (current US$) of Jordan in 2006 to that in 2009?
Your response must be concise. 0.6. What is the ratio of the Value added (current US$) of Tajikistan in 2006 to that in 2009?
Keep it short and to the point. 0.66. What is the ratio of the Value added (current US$) of Small states in 2007 to that in 2008?
Give a very brief answer. 0.92. What is the ratio of the Value added (current US$) of Cameroon in 2007 to that in 2008?
Make the answer very short. 0.86. What is the ratio of the Value added (current US$) of Jordan in 2007 to that in 2008?
Make the answer very short. 0.82. What is the ratio of the Value added (current US$) in Tajikistan in 2007 to that in 2008?
Your answer should be compact. 0.7. What is the ratio of the Value added (current US$) of Small states in 2007 to that in 2009?
Keep it short and to the point. 0.93. What is the ratio of the Value added (current US$) in Cameroon in 2007 to that in 2009?
Your answer should be very brief. 0.85. What is the ratio of the Value added (current US$) in Jordan in 2007 to that in 2009?
Your answer should be compact. 0.67. What is the ratio of the Value added (current US$) in Tajikistan in 2007 to that in 2009?
Your answer should be very brief. 0.78. What is the ratio of the Value added (current US$) of Small states in 2008 to that in 2009?
Offer a very short reply. 1.01. What is the ratio of the Value added (current US$) of Cameroon in 2008 to that in 2009?
Provide a short and direct response. 1. What is the ratio of the Value added (current US$) of Jordan in 2008 to that in 2009?
Your response must be concise. 0.82. What is the ratio of the Value added (current US$) in Tajikistan in 2008 to that in 2009?
Give a very brief answer. 1.11. What is the difference between the highest and the second highest Value added (current US$) in Small states?
Provide a succinct answer. 1.07e+08. What is the difference between the highest and the second highest Value added (current US$) of Cameroon?
Offer a very short reply. 2.41e+07. What is the difference between the highest and the second highest Value added (current US$) of Jordan?
Offer a very short reply. 1.16e+08. What is the difference between the highest and the second highest Value added (current US$) in Tajikistan?
Your answer should be very brief. 1.02e+08. What is the difference between the highest and the lowest Value added (current US$) of Small states?
Offer a terse response. 2.47e+09. What is the difference between the highest and the lowest Value added (current US$) of Cameroon?
Your response must be concise. 2.32e+09. What is the difference between the highest and the lowest Value added (current US$) of Jordan?
Your answer should be very brief. 3.95e+08. What is the difference between the highest and the lowest Value added (current US$) in Tajikistan?
Offer a terse response. 6.49e+08. 